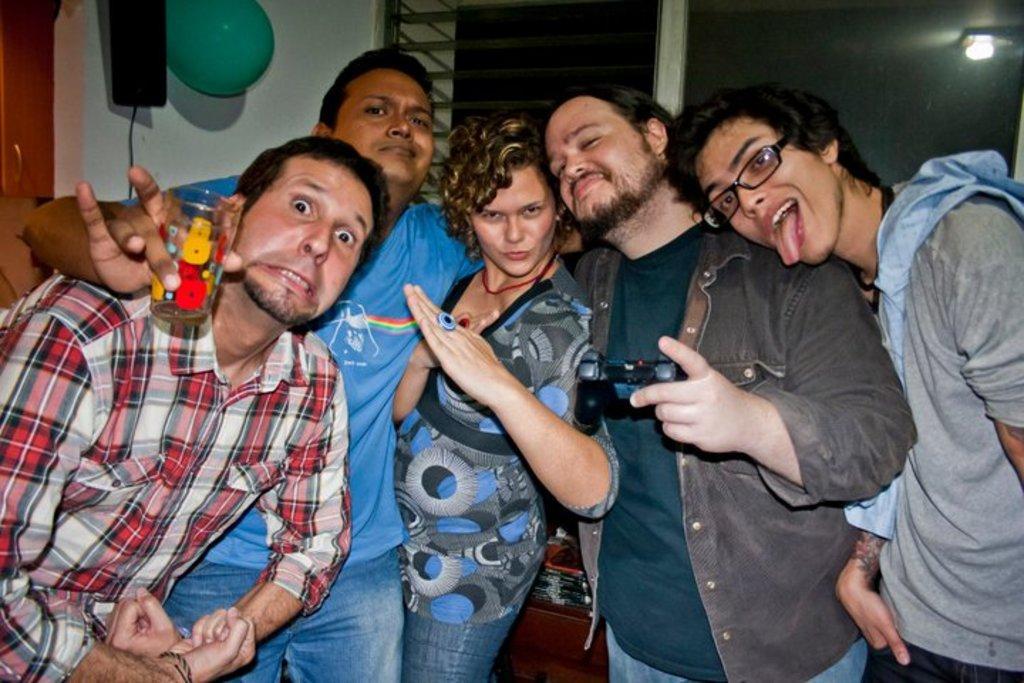Can you describe this image briefly? In this picture I can see five persons standing, there is a balloon and some other objects, there is a wall with a window, and there is a reflection of light. 